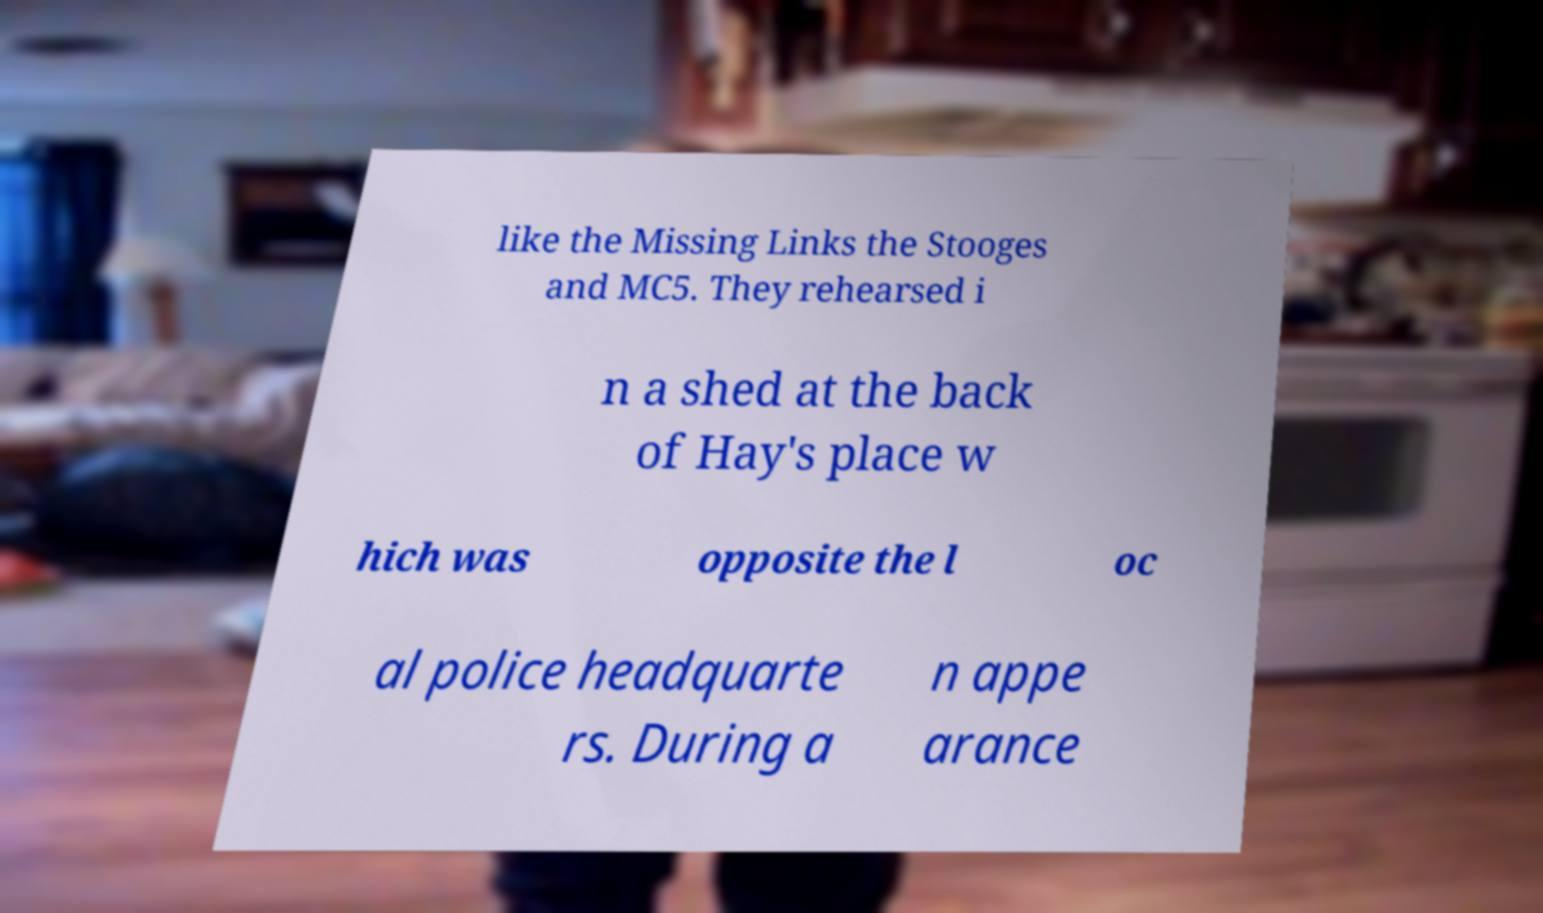Can you read and provide the text displayed in the image?This photo seems to have some interesting text. Can you extract and type it out for me? like the Missing Links the Stooges and MC5. They rehearsed i n a shed at the back of Hay's place w hich was opposite the l oc al police headquarte rs. During a n appe arance 